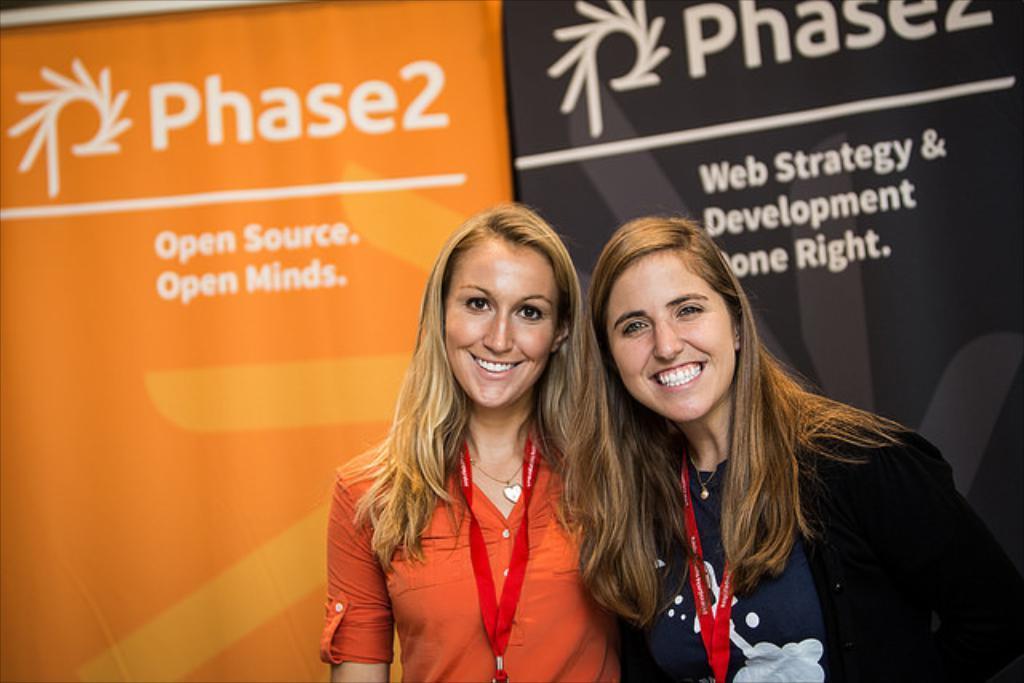Can you describe this image briefly? In this image there are two ladies wearing id tags and standing, in the background there are two banners, on that banners there is some text. 